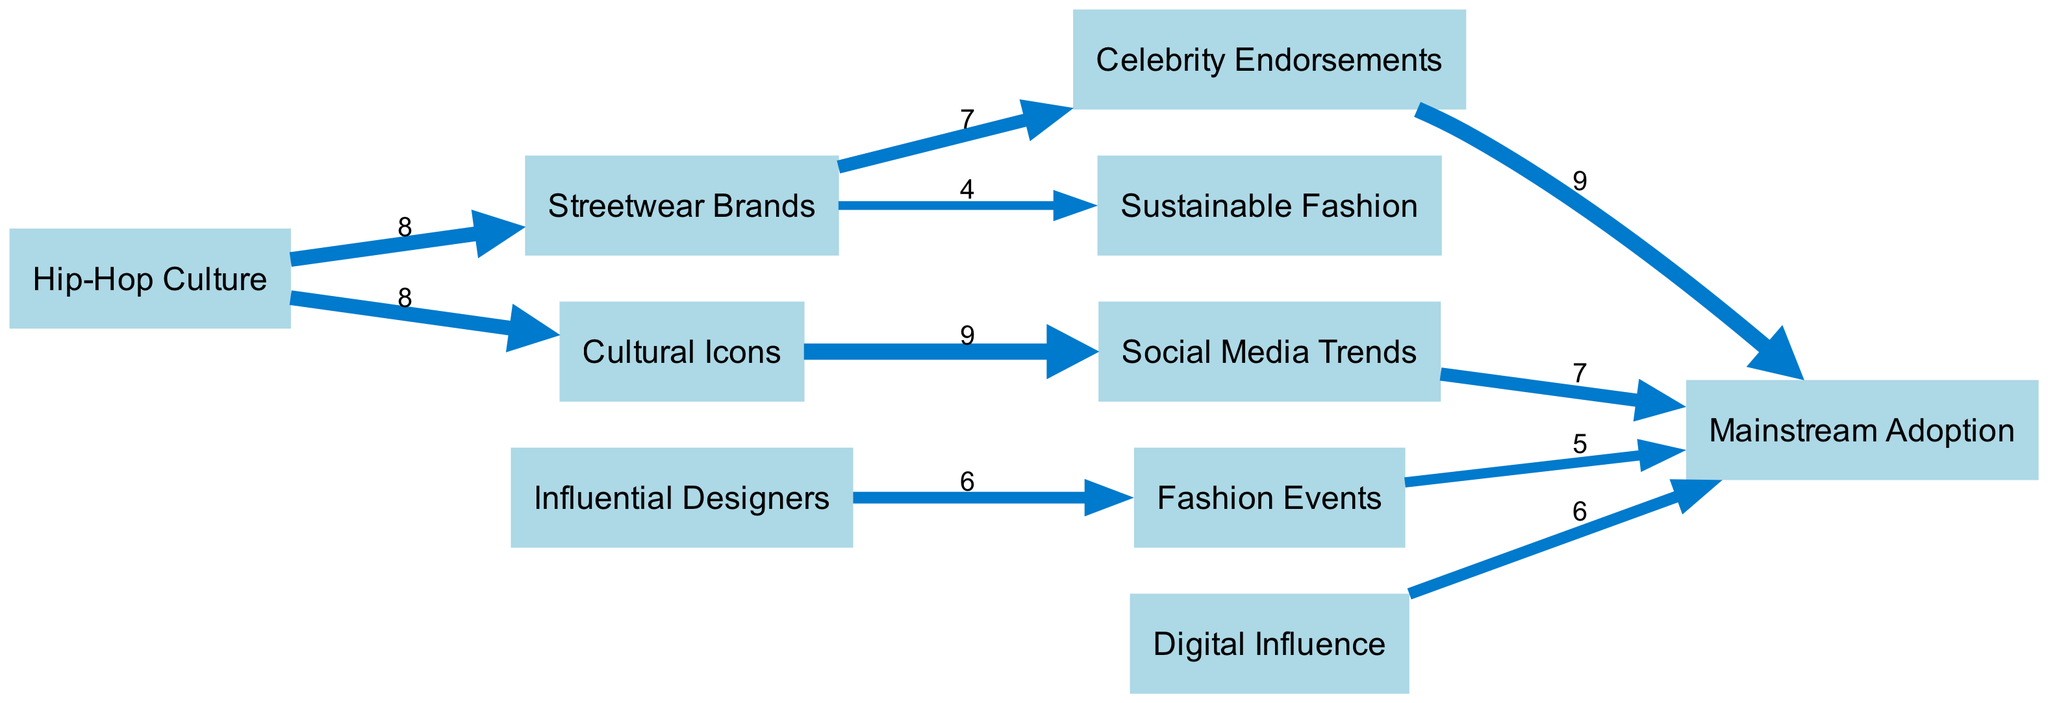What is the total number of nodes in the diagram? The diagram lists 10 unique nodes representing different aspects of African American fashion trends and their impact on mainstream culture: Hip-Hop Culture, Streetwear Brands, Influential Designers, Celebrity Endorsements, Fashion Events, Mainstream Adoption, Sustainable Fashion, Digital Influence, Cultural Icons, and Social Media Trends. Combining them gives a total of 10 nodes.
Answer: 10 Which node has the highest flow value? By inspecting the links in the diagram, the highest value flows from Cultural Icons to Social Media Trends, with a value of 9. This indicates a strong influence from cultural icons on social media trends, making them the most impactful connection.
Answer: 9 What is the flow value from Streetwear Brands to Celebrity Endorsements? The diagram provides a direct link from Streetwear Brands to Celebrity Endorsements with a flow value of 7. This depicts a significant relationship where streetwear brands are heavily endorsed by celebrities.
Answer: 7 How many total flows lead to Mainstream Adoption? Multiple links connect to Mainstream Adoption: from Celebrity Endorsements (value 9), Fashion Events (value 5), Social Media Trends (value 7), and Digital Influence (value 6). Summing these values gives a total of 27, reflecting the combined influences feeding into mainstream fashion culture.
Answer: 27 Which source has the lowest flow to another node? Inspecting the various links, the source with the lowest flow is Streetwear Brands to Sustainable Fashion, which has a flow value of 4. This indicates it is the weakest connection in terms of influence on sustainable fashion trends compared to others.
Answer: 4 What is the relationship between Hip-Hop Culture and Mainstream Adoption? The diagram indicates that Hip-Hop Culture directly influences Mainstream Adoption through two distinct paths: first, it flows to Streetwear Brands (value 8), which then leads to Celebrity Endorsements (value 7), ultimately resulting in a substantial contribution to Mainstream Adoption (value 9).
Answer: Strong influence How does Digital Influence relate to Mainstream Adoption? Digital Influence has a direct link to Mainstream Adoption with a flow value of 6. This signifies that the impact of digital platforms plays a key role in the adoption of fashion trends in mainstream culture.
Answer: 6 Which trend connects Cultural Icons to Social Media Trends? The trend directly connecting Cultural Icons to Social Media Trends is a strong cultural flow with a value of 9. This connection suggests that cultural icons heavily impact what becomes popular on social media, emphasizing their role in fashion dissemination.
Answer: 9 